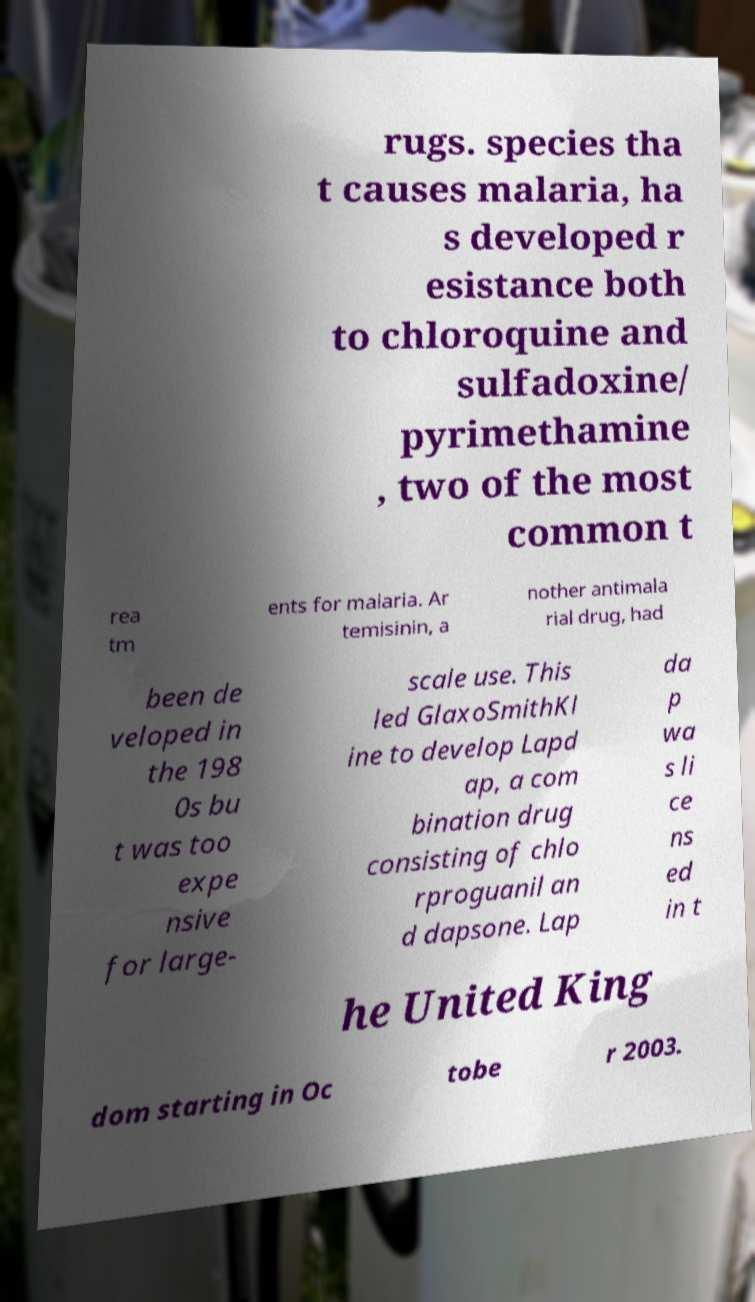Can you accurately transcribe the text from the provided image for me? rugs. species tha t causes malaria, ha s developed r esistance both to chloroquine and sulfadoxine/ pyrimethamine , two of the most common t rea tm ents for malaria. Ar temisinin, a nother antimala rial drug, had been de veloped in the 198 0s bu t was too expe nsive for large- scale use. This led GlaxoSmithKl ine to develop Lapd ap, a com bination drug consisting of chlo rproguanil an d dapsone. Lap da p wa s li ce ns ed in t he United King dom starting in Oc tobe r 2003. 